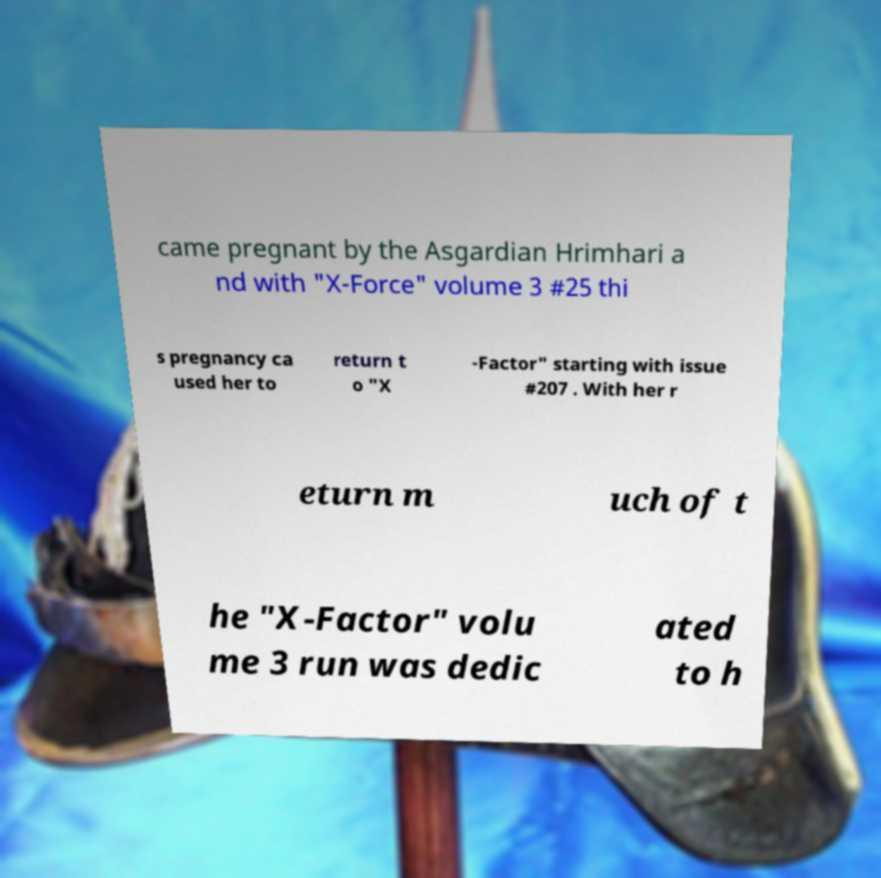Please identify and transcribe the text found in this image. came pregnant by the Asgardian Hrimhari a nd with "X-Force" volume 3 #25 thi s pregnancy ca used her to return t o "X -Factor" starting with issue #207 . With her r eturn m uch of t he "X-Factor" volu me 3 run was dedic ated to h 